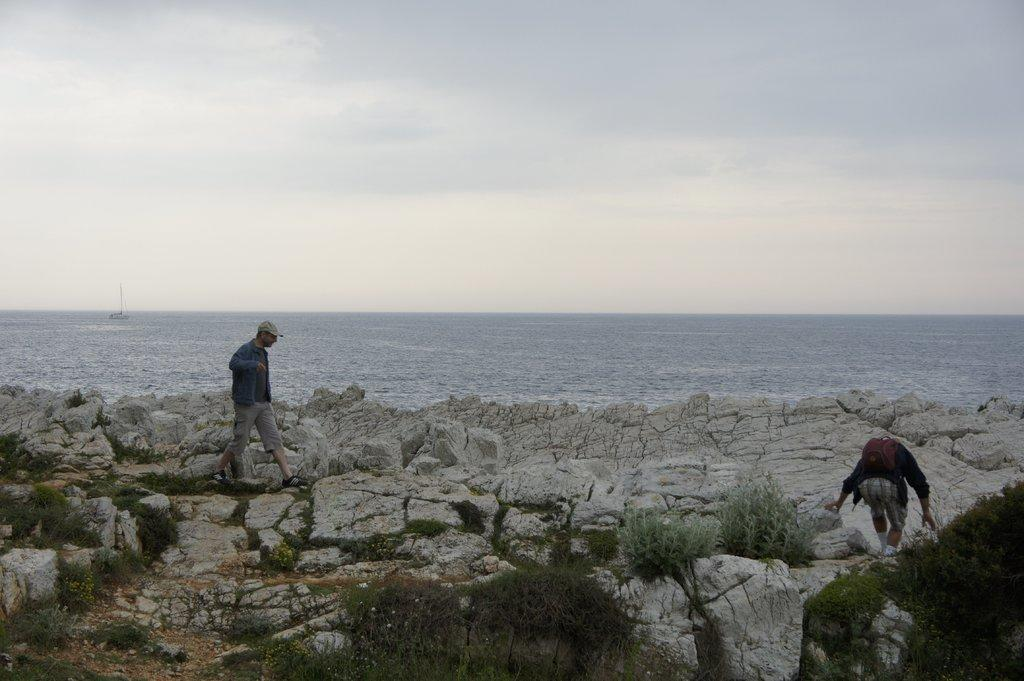How many people are in the image? There are two people in the image. What is one of the people doing in the image? A man is walking on rocks. What type of natural environment is depicted in the image? Plants and water are present in the image, suggesting a natural setting. What is visible in the background of the image? The sky is visible in the background of the image. What can be seen in the sky? Clouds are present in the sky. What type of work is the man doing with the lake in the image? There is no lake present in the image, and the man is not performing any work-related activities. What phase of the moon can be seen in the image? The moon is not visible in the image. 